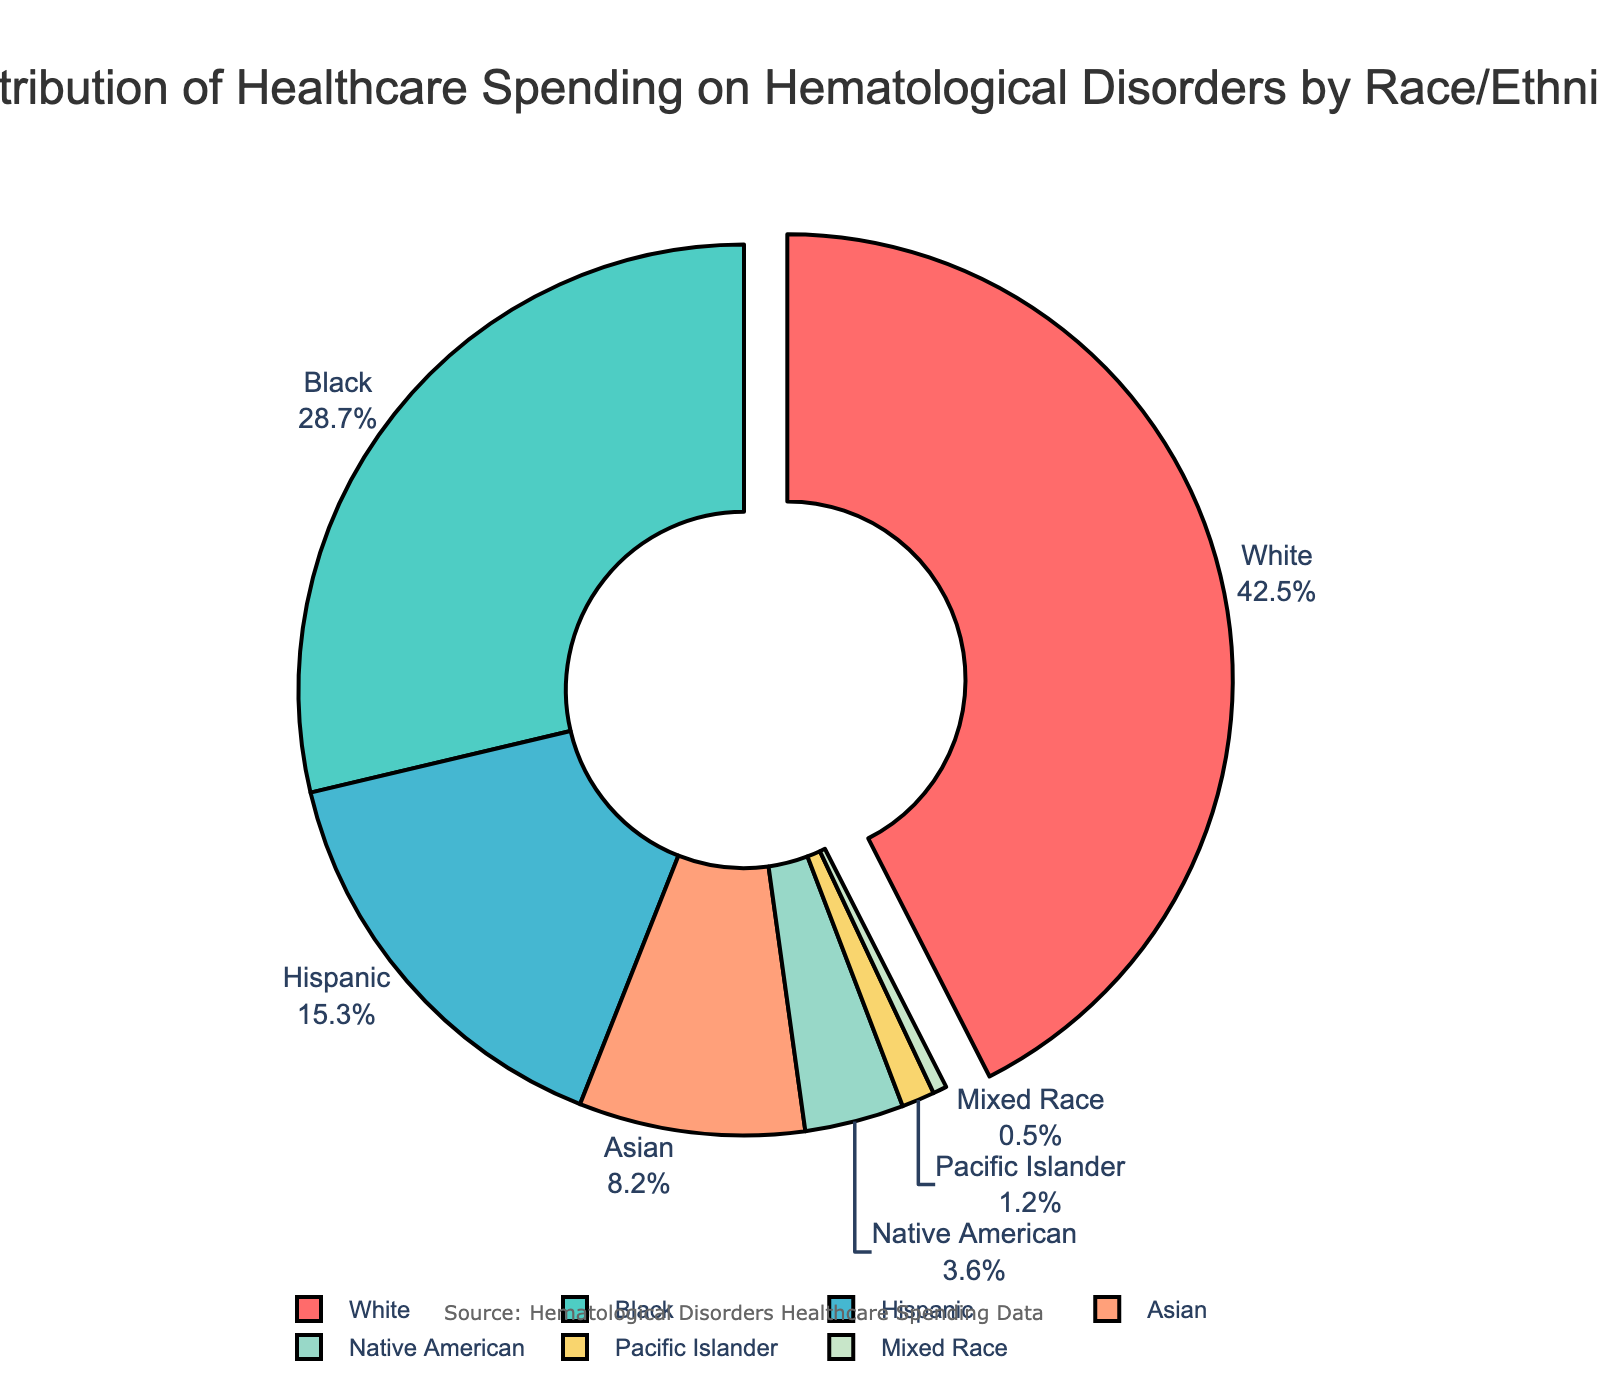What percentage of healthcare spending on hematological disorders is attributed to Black individuals? Locate the segment labeled "Black" on the pie chart. The label text should include the percentage.
Answer: 28.7% How much more is the percentage of spending on White individuals compared to Hispanic individuals? Identify the percentages for White (42.5%) and Hispanic (15.3%). Subtract the percentage for Hispanic from the percentage for White (42.5 - 15.3).
Answer: 27.2% Which racial group has the lowest percentage of healthcare spending, and what is that percentage? Find the smallest segment in the pie chart and its label. The label "Mixed Race" should show the lowest percentage.
Answer: Mixed Race, 0.5% Are the spending percentages for Native American and Pacific Islander combined greater than the spending for Asian individuals? Add the percentages for Native American (3.6%) and Pacific Islander (1.2%). Then compare the sum to the percentage for Asian (3.6 + 1.2 = 4.8; 4.8 > 8.2).
Answer: No What is the combined percentage of healthcare spending on Black and Hispanic individuals? Locate the percentages for both Black (28.7%) and Hispanic (15.3%). Sum the two percentages (28.7 + 15.3).
Answer: 44% Which racial group has the largest spending percentage, and what visual feature highlights this group in the pie chart? Identify the segment with the highest value in the pie chart. The "White" group's segment should also be slightly pulled out from the center.
Answer: White, segment slightly pulled out What is the difference in healthcare spending percentages between Asian and Native American individuals? Identify the percentages for Asian (8.2%) and Native American (3.6%). Subtract the percentage for Native American from the percentage for Asian (8.2 - 3.6).
Answer: 4.6% What is the average percentage of healthcare spending for the Native American, Pacific Islander, and Mixed Race groups? Locate the percentages for Native American (3.6%), Pacific Islander (1.2%), and Mixed Race (0.5%). Sum these percentages and then divide by three (3.6 + 1.2 + 0.5) / 3.
Answer: 1.77% Which group's segment color is green, and what is its percentage of healthcare spending? Visually identify the green-colored segment in the pie chart. The label "Black" should indicate the percentage.
Answer: Black, 28.7% 